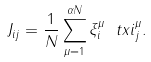<formula> <loc_0><loc_0><loc_500><loc_500>J _ { i j } = \frac { 1 } { N } \sum _ { \mu = 1 } ^ { \alpha N } \xi ^ { \mu } _ { i } \ t x i ^ { \mu } _ { j } .</formula> 